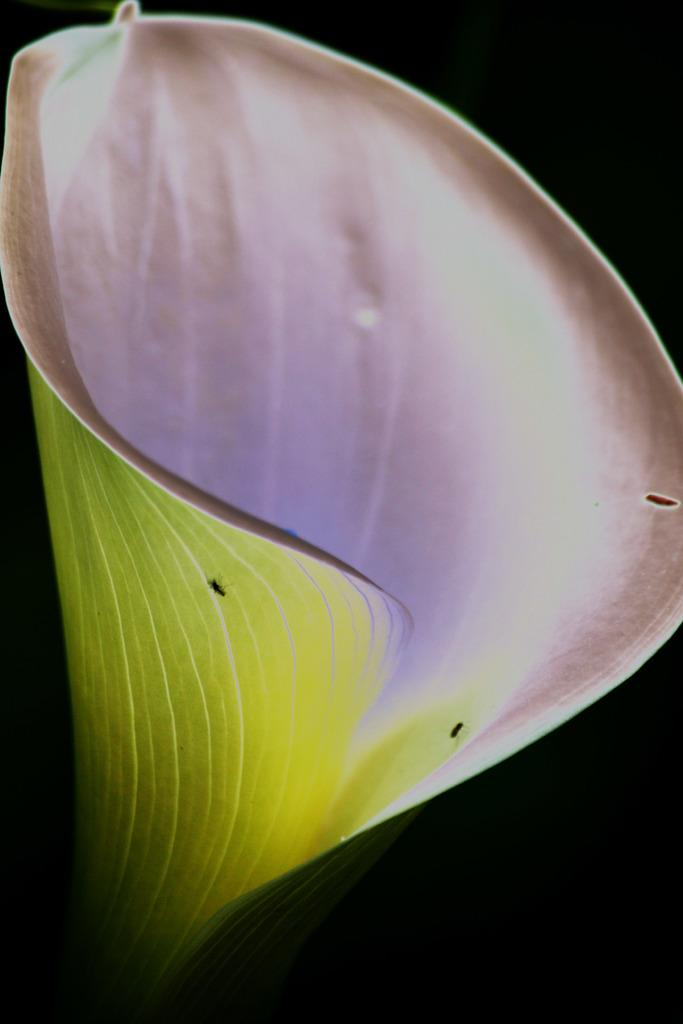What is the main subject of the image? There is a flower in the image. Are there any other living organisms present on the flower? Yes, there are insects on the flower. What color is the background of the image? The background of the image is black. What type of music can be heard coming from the flower in the image? There is no music present in the image; it features a flower with insects on it and a black background. 